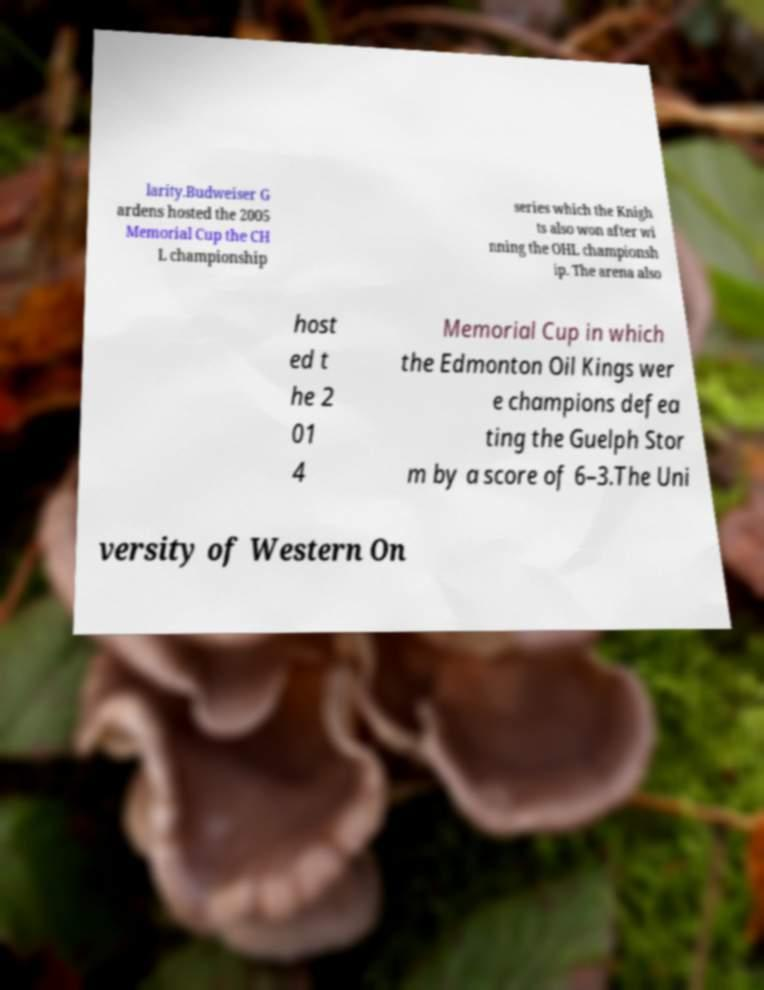Please read and relay the text visible in this image. What does it say? larity.Budweiser G ardens hosted the 2005 Memorial Cup the CH L championship series which the Knigh ts also won after wi nning the OHL championsh ip. The arena also host ed t he 2 01 4 Memorial Cup in which the Edmonton Oil Kings wer e champions defea ting the Guelph Stor m by a score of 6–3.The Uni versity of Western On 